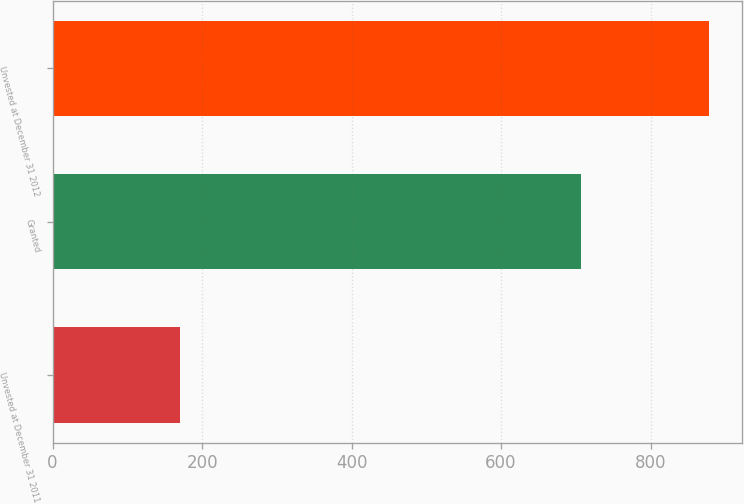Convert chart. <chart><loc_0><loc_0><loc_500><loc_500><bar_chart><fcel>Unvested at December 31 2011<fcel>Granted<fcel>Unvested at December 31 2012<nl><fcel>171<fcel>707<fcel>878<nl></chart> 